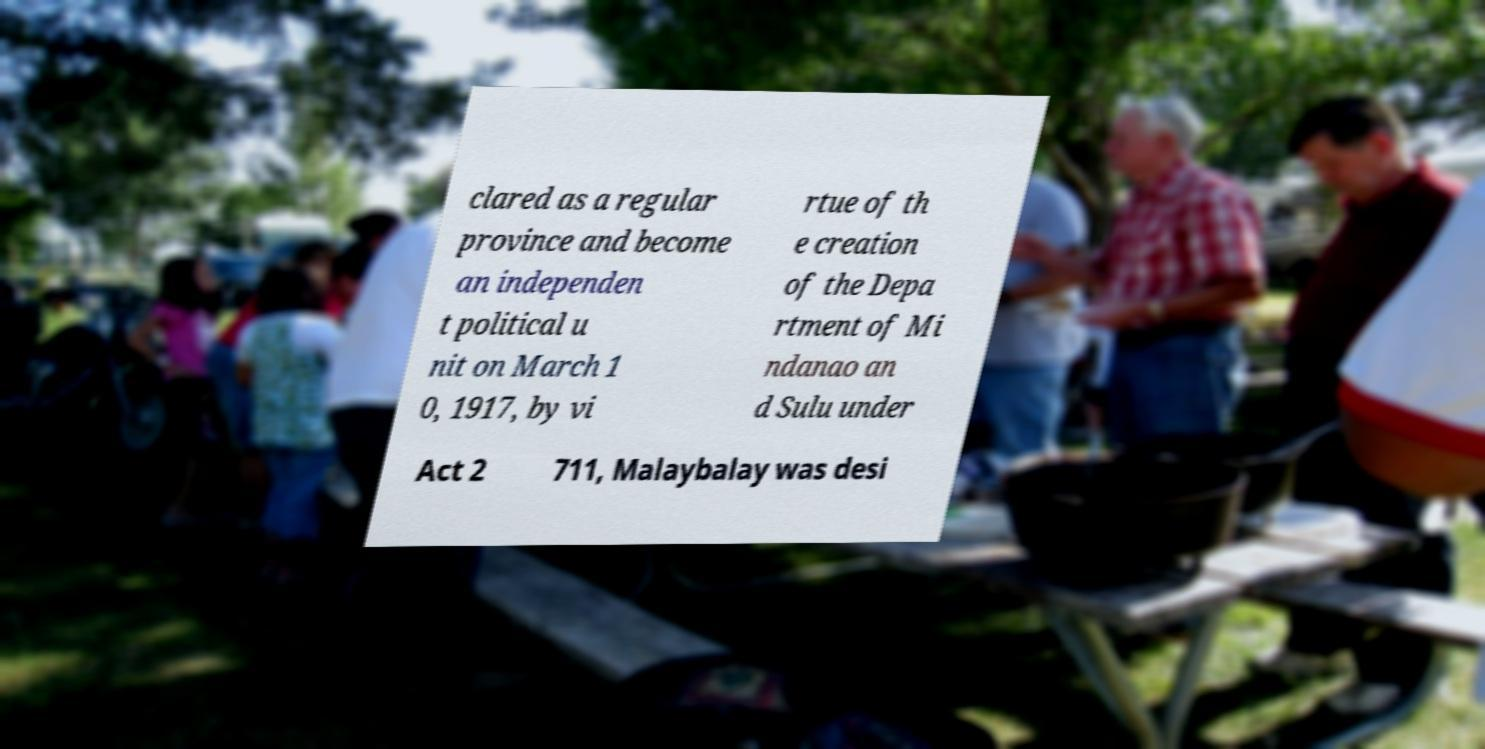I need the written content from this picture converted into text. Can you do that? clared as a regular province and become an independen t political u nit on March 1 0, 1917, by vi rtue of th e creation of the Depa rtment of Mi ndanao an d Sulu under Act 2 711, Malaybalay was desi 